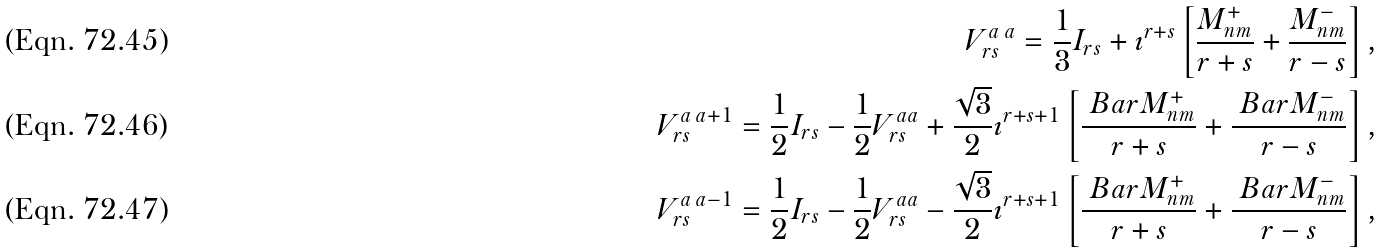<formula> <loc_0><loc_0><loc_500><loc_500>V ^ { a \, a } _ { r s } = \frac { 1 } { 3 } I _ { r s } + \imath ^ { r + s } \left [ \frac { M ^ { + } _ { n m } } { r + s } + \frac { M ^ { - } _ { n m } } { r - s } \right ] , \\ V ^ { a \, a + 1 } _ { r s } = \frac { 1 } { 2 } I _ { r s } - \frac { 1 } { 2 } V ^ { a a } _ { r s } + \frac { \sqrt { 3 } } { 2 } \imath ^ { r + s + 1 } \left [ \frac { \ B a r { M } ^ { + } _ { n m } } { r + s } + \frac { \ B a r { M } ^ { - } _ { n m } } { r - s } \right ] , \\ V ^ { a \, a - 1 } _ { r s } = \frac { 1 } { 2 } I _ { r s } - \frac { 1 } { 2 } V ^ { a a } _ { r s } - \frac { \sqrt { 3 } } { 2 } \imath ^ { r + s + 1 } \left [ \frac { \ B a r { M } ^ { + } _ { n m } } { r + s } + \frac { \ B a r { M } ^ { - } _ { n m } } { r - s } \right ] ,</formula> 